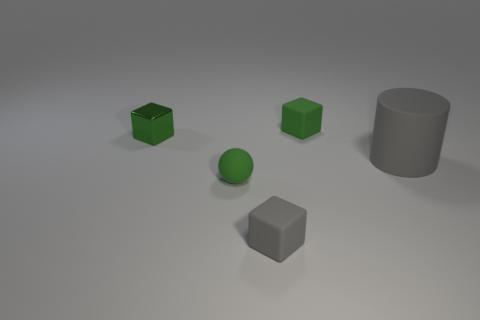How many green cubes must be subtracted to get 1 green cubes? 1 Add 1 small matte spheres. How many objects exist? 6 Subtract all cylinders. How many objects are left? 4 Add 1 small green cubes. How many small green cubes exist? 3 Subtract 0 green cylinders. How many objects are left? 5 Subtract all small red balls. Subtract all large gray objects. How many objects are left? 4 Add 2 green things. How many green things are left? 5 